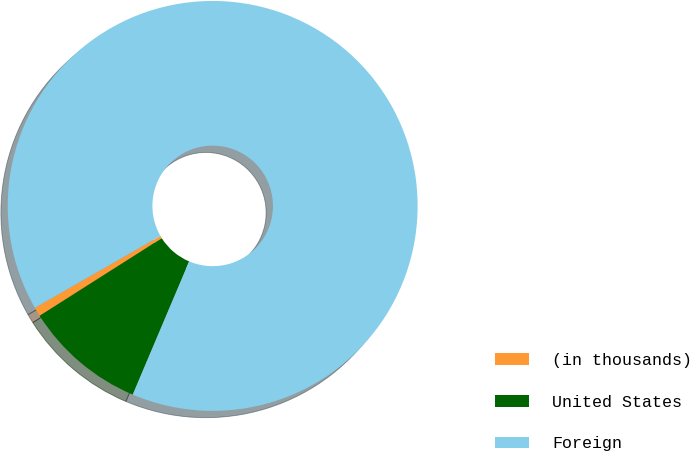<chart> <loc_0><loc_0><loc_500><loc_500><pie_chart><fcel>(in thousands)<fcel>United States<fcel>Foreign<nl><fcel>0.72%<fcel>9.62%<fcel>89.66%<nl></chart> 